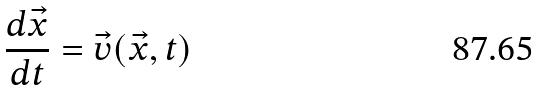Convert formula to latex. <formula><loc_0><loc_0><loc_500><loc_500>\frac { d \vec { x } } { d t } = \vec { v } ( \vec { x } , t )</formula> 